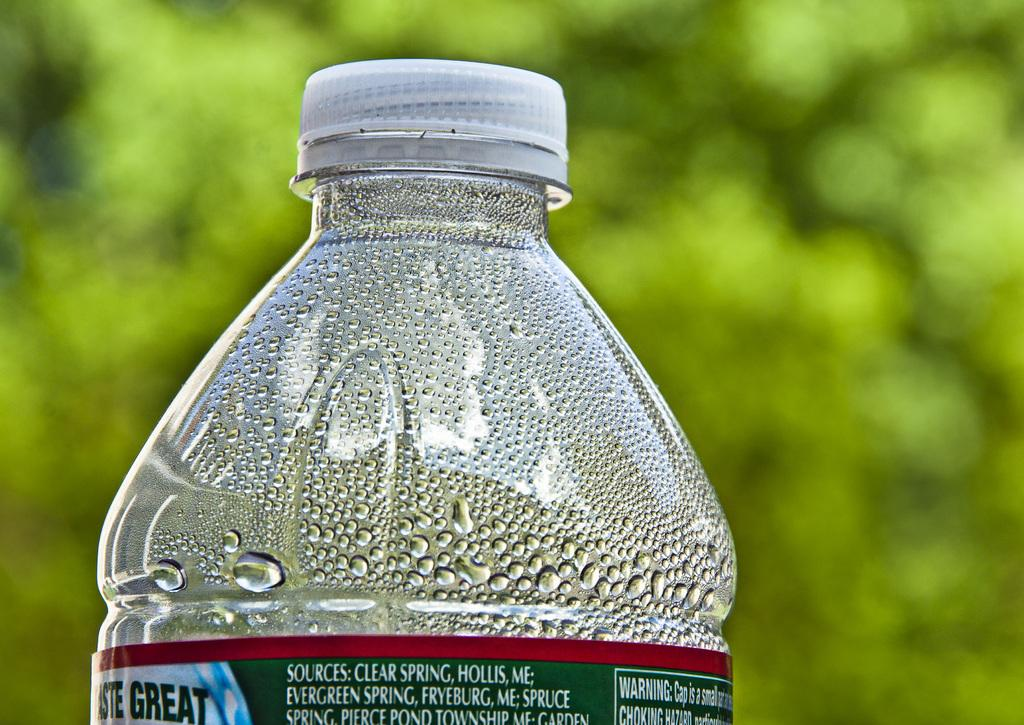<image>
Describe the image concisely. Clear spring water from the mountains of Maine. 